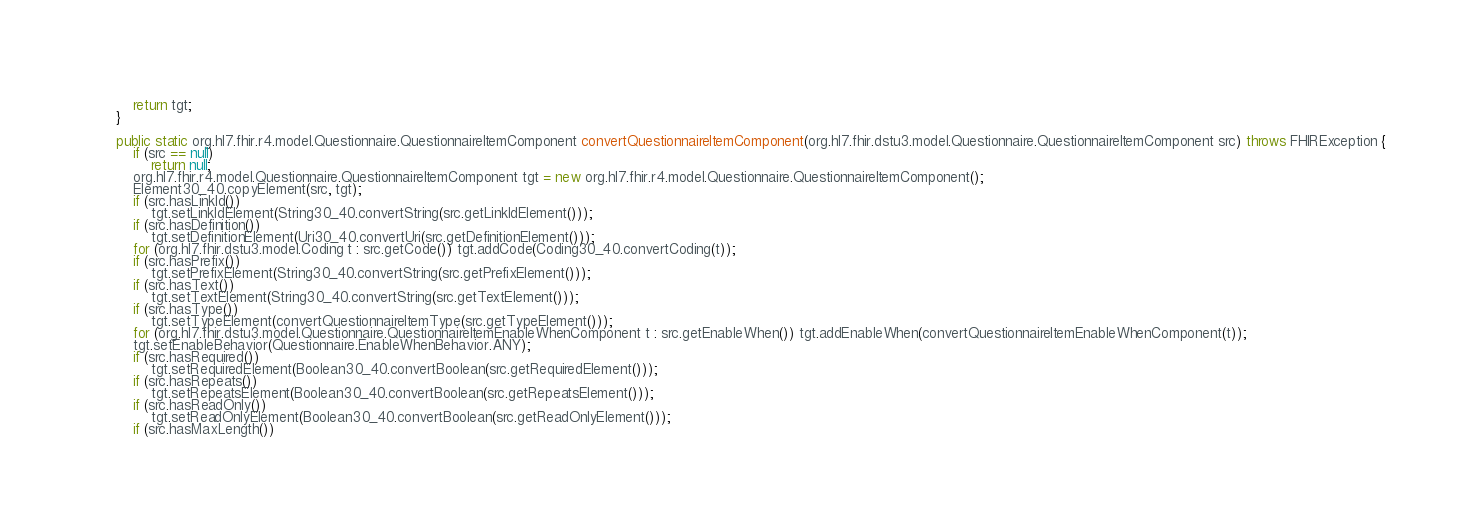<code> <loc_0><loc_0><loc_500><loc_500><_Java_>        return tgt;
    }

    public static org.hl7.fhir.r4.model.Questionnaire.QuestionnaireItemComponent convertQuestionnaireItemComponent(org.hl7.fhir.dstu3.model.Questionnaire.QuestionnaireItemComponent src) throws FHIRException {
        if (src == null)
            return null;
        org.hl7.fhir.r4.model.Questionnaire.QuestionnaireItemComponent tgt = new org.hl7.fhir.r4.model.Questionnaire.QuestionnaireItemComponent();
        Element30_40.copyElement(src, tgt);
        if (src.hasLinkId())
            tgt.setLinkIdElement(String30_40.convertString(src.getLinkIdElement()));
        if (src.hasDefinition())
            tgt.setDefinitionElement(Uri30_40.convertUri(src.getDefinitionElement()));
        for (org.hl7.fhir.dstu3.model.Coding t : src.getCode()) tgt.addCode(Coding30_40.convertCoding(t));
        if (src.hasPrefix())
            tgt.setPrefixElement(String30_40.convertString(src.getPrefixElement()));
        if (src.hasText())
            tgt.setTextElement(String30_40.convertString(src.getTextElement()));
        if (src.hasType())
            tgt.setTypeElement(convertQuestionnaireItemType(src.getTypeElement()));
        for (org.hl7.fhir.dstu3.model.Questionnaire.QuestionnaireItemEnableWhenComponent t : src.getEnableWhen()) tgt.addEnableWhen(convertQuestionnaireItemEnableWhenComponent(t));
        tgt.setEnableBehavior(Questionnaire.EnableWhenBehavior.ANY);
        if (src.hasRequired())
            tgt.setRequiredElement(Boolean30_40.convertBoolean(src.getRequiredElement()));
        if (src.hasRepeats())
            tgt.setRepeatsElement(Boolean30_40.convertBoolean(src.getRepeatsElement()));
        if (src.hasReadOnly())
            tgt.setReadOnlyElement(Boolean30_40.convertBoolean(src.getReadOnlyElement()));
        if (src.hasMaxLength())</code> 